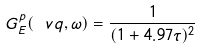Convert formula to latex. <formula><loc_0><loc_0><loc_500><loc_500>G _ { E } ^ { p } ( \ v { q } , \omega ) = \frac { 1 } { ( 1 + 4 . 9 7 \tau ) ^ { 2 } }</formula> 